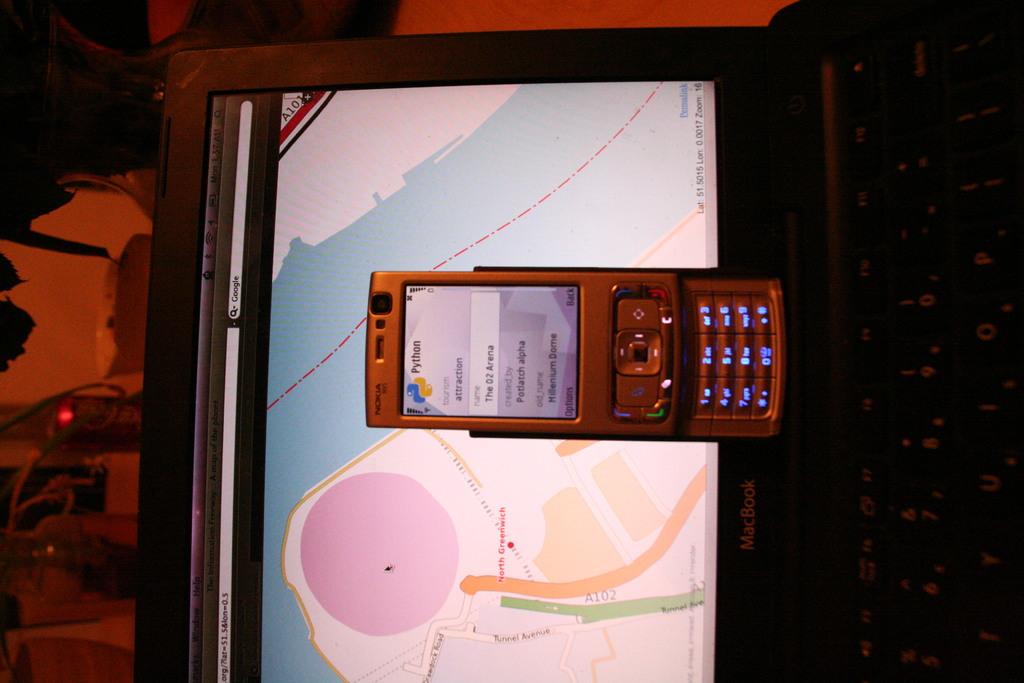What brand of phone is this?
Give a very brief answer. Nokia. 